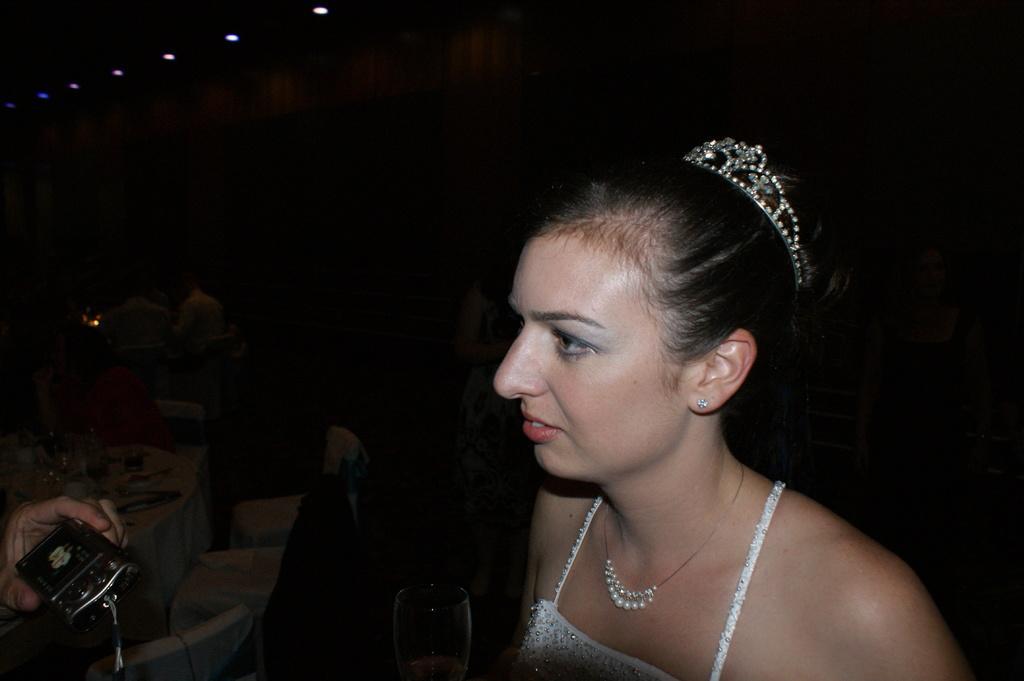Could you give a brief overview of what you see in this image? In this image I can see a woman, I can see she is wearing white dress, necklace and a crown on her head. Here I can see a hand of a person is holding a camera and in the background I can see few chairs, a table and few people over there. I can also see this image is little bit in dark from background. 